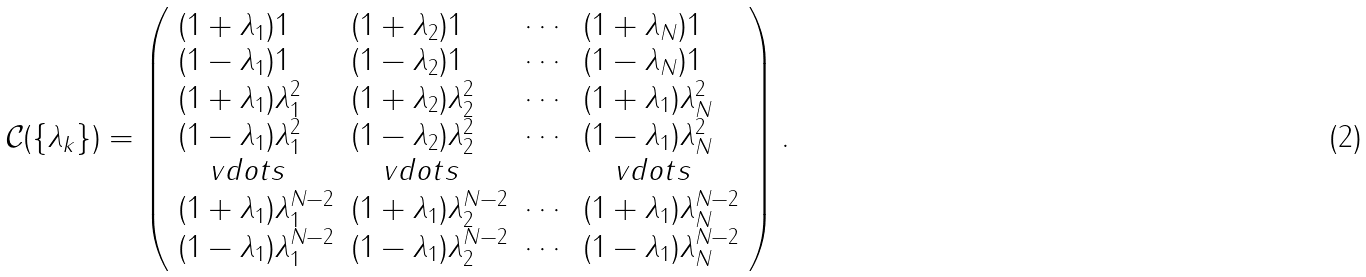Convert formula to latex. <formula><loc_0><loc_0><loc_500><loc_500>\mathcal { C } ( \{ \lambda _ { k } \} ) = \left ( \begin{array} { l l l l } ( 1 + \lambda _ { 1 } ) 1 & ( 1 + \lambda _ { 2 } ) 1 & \cdots & ( 1 + \lambda _ { N } ) 1 \\ ( 1 - \lambda _ { 1 } ) 1 & ( 1 - \lambda _ { 2 } ) 1 & \cdots & ( 1 - \lambda _ { N } ) 1 \\ ( 1 + \lambda _ { 1 } ) \lambda _ { 1 } ^ { 2 } & ( 1 + \lambda _ { 2 } ) \lambda _ { 2 } ^ { 2 } & \cdots & ( 1 + \lambda _ { 1 } ) \lambda _ { N } ^ { 2 } \\ ( 1 - \lambda _ { 1 } ) \lambda _ { 1 } ^ { 2 } & ( 1 - \lambda _ { 2 } ) \lambda _ { 2 } ^ { 2 } & \cdots & ( 1 - \lambda _ { 1 } ) \lambda _ { N } ^ { 2 } \\ \quad v d o t s & \quad v d o t s & & \quad v d o t s \\ ( 1 + \lambda _ { 1 } ) \lambda _ { 1 } ^ { N - 2 } & ( 1 + \lambda _ { 1 } ) \lambda _ { 2 } ^ { N - 2 } & \cdots & ( 1 + \lambda _ { 1 } ) \lambda _ { N } ^ { N - 2 } \\ ( 1 - \lambda _ { 1 } ) \lambda _ { 1 } ^ { N - 2 } & ( 1 - \lambda _ { 1 } ) \lambda _ { 2 } ^ { N - 2 } & \cdots & ( 1 - \lambda _ { 1 } ) \lambda _ { N } ^ { N - 2 } \\ \end{array} \right ) .</formula> 